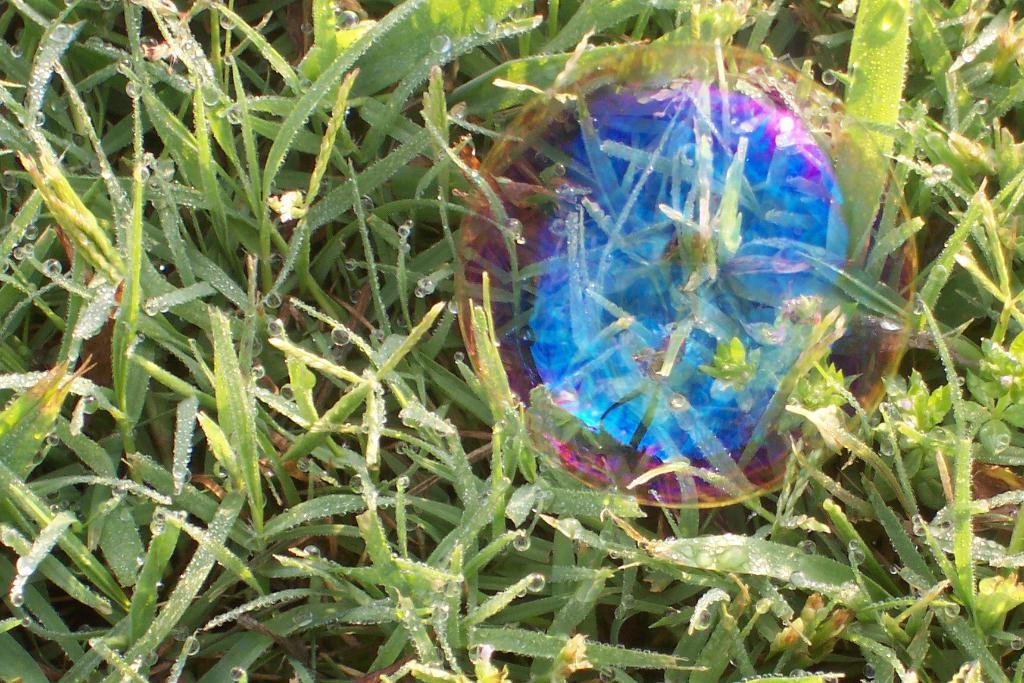What type of living organisms can be seen in the image? Plants can be seen in the image. What else is present in the image besides plants? There are bubbles in the image. What month is it in the image? The month cannot be determined from the image, as there is no information about the time of year. 